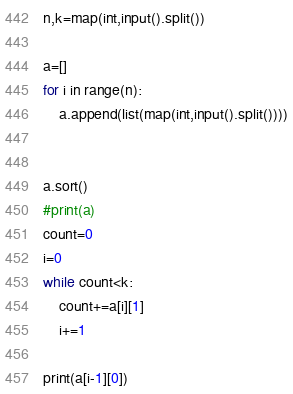Convert code to text. <code><loc_0><loc_0><loc_500><loc_500><_Python_>n,k=map(int,input().split())

a=[]
for i in range(n):
    a.append(list(map(int,input().split())))


a.sort()
#print(a)
count=0
i=0
while count<k:
    count+=a[i][1]
    i+=1

print(a[i-1][0])</code> 